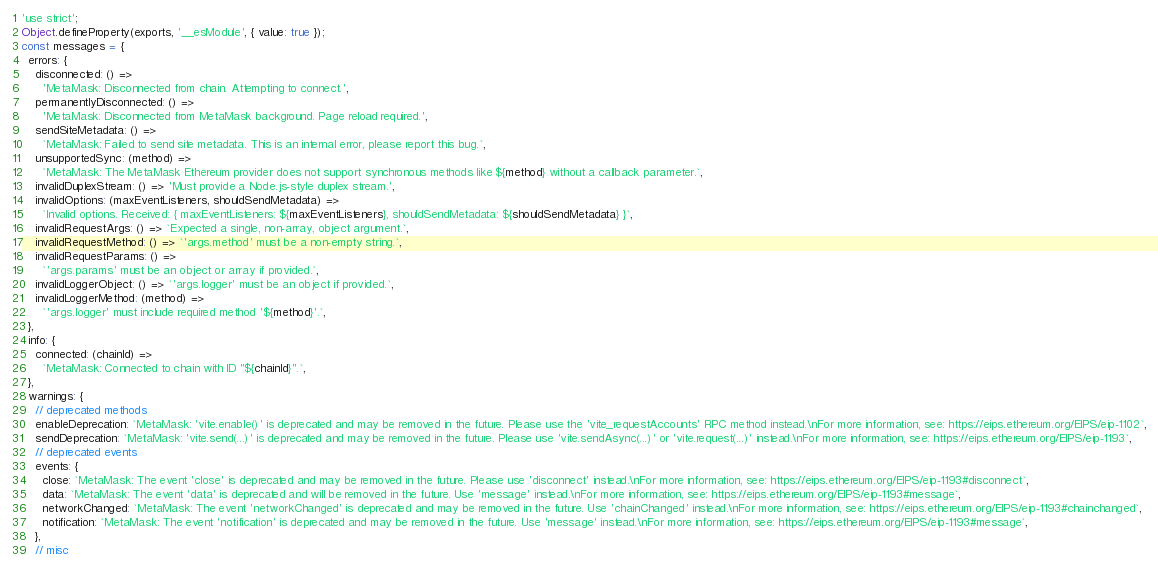<code> <loc_0><loc_0><loc_500><loc_500><_JavaScript_>'use strict';
Object.defineProperty(exports, '__esModule', { value: true });
const messages = {
  errors: {
    disconnected: () =>
      'MetaMask: Disconnected from chain. Attempting to connect.',
    permanentlyDisconnected: () =>
      'MetaMask: Disconnected from MetaMask background. Page reload required.',
    sendSiteMetadata: () =>
      `MetaMask: Failed to send site metadata. This is an internal error, please report this bug.`,
    unsupportedSync: (method) =>
      `MetaMask: The MetaMask Ethereum provider does not support synchronous methods like ${method} without a callback parameter.`,
    invalidDuplexStream: () => 'Must provide a Node.js-style duplex stream.',
    invalidOptions: (maxEventListeners, shouldSendMetadata) =>
      `Invalid options. Received: { maxEventListeners: ${maxEventListeners}, shouldSendMetadata: ${shouldSendMetadata} }`,
    invalidRequestArgs: () => `Expected a single, non-array, object argument.`,
    invalidRequestMethod: () => `'args.method' must be a non-empty string.`,
    invalidRequestParams: () =>
      `'args.params' must be an object or array if provided.`,
    invalidLoggerObject: () => `'args.logger' must be an object if provided.`,
    invalidLoggerMethod: (method) =>
      `'args.logger' must include required method '${method}'.`,
  },
  info: {
    connected: (chainId) =>
      `MetaMask: Connected to chain with ID "${chainId}".`,
  },
  warnings: {
    // deprecated methods
    enableDeprecation: `MetaMask: 'vite.enable()' is deprecated and may be removed in the future. Please use the 'vite_requestAccounts' RPC method instead.\nFor more information, see: https://eips.ethereum.org/EIPS/eip-1102`,
    sendDeprecation: `MetaMask: 'vite.send(...)' is deprecated and may be removed in the future. Please use 'vite.sendAsync(...)' or 'vite.request(...)' instead.\nFor more information, see: https://eips.ethereum.org/EIPS/eip-1193`,
    // deprecated events
    events: {
      close: `MetaMask: The event 'close' is deprecated and may be removed in the future. Please use 'disconnect' instead.\nFor more information, see: https://eips.ethereum.org/EIPS/eip-1193#disconnect`,
      data: `MetaMask: The event 'data' is deprecated and will be removed in the future. Use 'message' instead.\nFor more information, see: https://eips.ethereum.org/EIPS/eip-1193#message`,
      networkChanged: `MetaMask: The event 'networkChanged' is deprecated and may be removed in the future. Use 'chainChanged' instead.\nFor more information, see: https://eips.ethereum.org/EIPS/eip-1193#chainchanged`,
      notification: `MetaMask: The event 'notification' is deprecated and may be removed in the future. Use 'message' instead.\nFor more information, see: https://eips.ethereum.org/EIPS/eip-1193#message`,
    },
    // misc</code> 